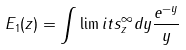Convert formula to latex. <formula><loc_0><loc_0><loc_500><loc_500>E _ { 1 } ( z ) = \int \lim i t s _ { z } ^ { \infty } { d y \frac { { e ^ { - y } } } y }</formula> 